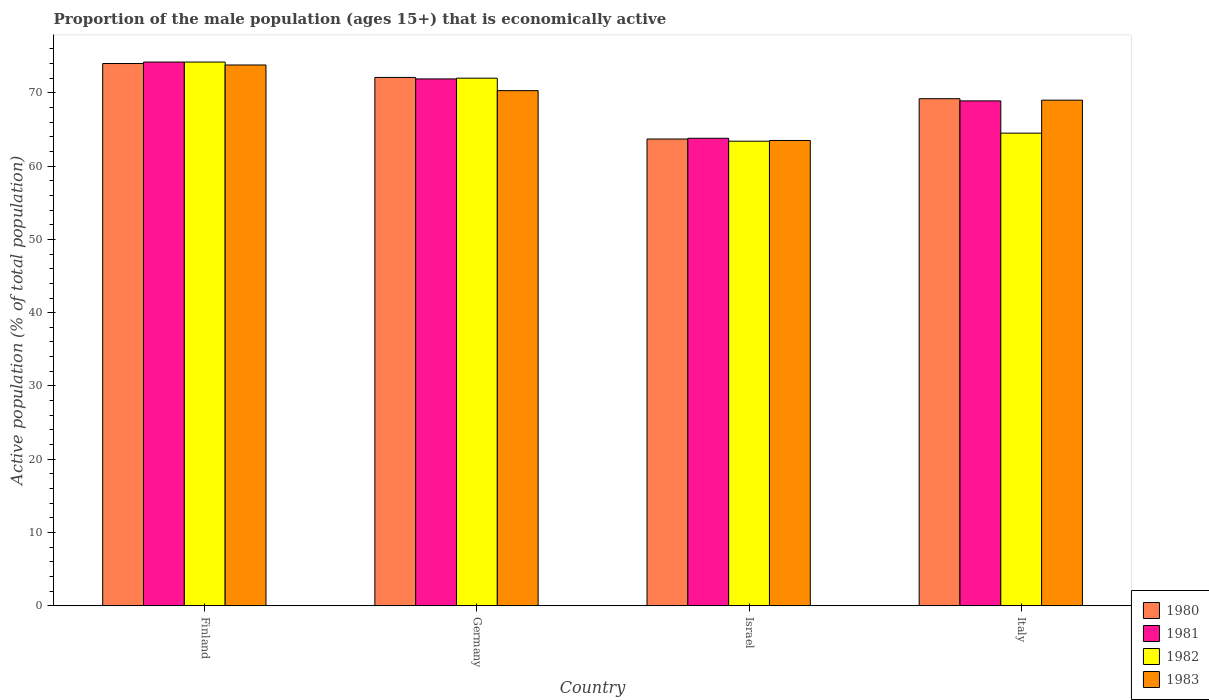Are the number of bars on each tick of the X-axis equal?
Your answer should be compact. Yes. How many bars are there on the 3rd tick from the left?
Keep it short and to the point. 4. What is the proportion of the male population that is economically active in 1982 in Finland?
Ensure brevity in your answer.  74.2. Across all countries, what is the maximum proportion of the male population that is economically active in 1983?
Provide a succinct answer. 73.8. Across all countries, what is the minimum proportion of the male population that is economically active in 1981?
Make the answer very short. 63.8. What is the total proportion of the male population that is economically active in 1981 in the graph?
Provide a short and direct response. 278.8. What is the difference between the proportion of the male population that is economically active in 1980 in Finland and that in Germany?
Your answer should be compact. 1.9. What is the difference between the proportion of the male population that is economically active in 1980 in Finland and the proportion of the male population that is economically active in 1983 in Italy?
Keep it short and to the point. 5. What is the average proportion of the male population that is economically active in 1983 per country?
Offer a terse response. 69.15. What is the difference between the proportion of the male population that is economically active of/in 1981 and proportion of the male population that is economically active of/in 1980 in Germany?
Your answer should be very brief. -0.2. What is the ratio of the proportion of the male population that is economically active in 1983 in Finland to that in Italy?
Your answer should be very brief. 1.07. What is the difference between the highest and the second highest proportion of the male population that is economically active in 1982?
Provide a short and direct response. -2.2. What is the difference between the highest and the lowest proportion of the male population that is economically active in 1982?
Your answer should be very brief. 10.8. Is it the case that in every country, the sum of the proportion of the male population that is economically active in 1981 and proportion of the male population that is economically active in 1982 is greater than the sum of proportion of the male population that is economically active in 1980 and proportion of the male population that is economically active in 1983?
Ensure brevity in your answer.  No. What does the 3rd bar from the left in Israel represents?
Keep it short and to the point. 1982. Is it the case that in every country, the sum of the proportion of the male population that is economically active in 1982 and proportion of the male population that is economically active in 1981 is greater than the proportion of the male population that is economically active in 1980?
Make the answer very short. Yes. How many bars are there?
Provide a short and direct response. 16. Are the values on the major ticks of Y-axis written in scientific E-notation?
Your answer should be compact. No. Does the graph contain any zero values?
Offer a terse response. No. Does the graph contain grids?
Your answer should be very brief. No. How are the legend labels stacked?
Offer a very short reply. Vertical. What is the title of the graph?
Provide a succinct answer. Proportion of the male population (ages 15+) that is economically active. Does "2005" appear as one of the legend labels in the graph?
Keep it short and to the point. No. What is the label or title of the Y-axis?
Keep it short and to the point. Active population (% of total population). What is the Active population (% of total population) of 1980 in Finland?
Provide a short and direct response. 74. What is the Active population (% of total population) of 1981 in Finland?
Ensure brevity in your answer.  74.2. What is the Active population (% of total population) in 1982 in Finland?
Ensure brevity in your answer.  74.2. What is the Active population (% of total population) in 1983 in Finland?
Provide a succinct answer. 73.8. What is the Active population (% of total population) in 1980 in Germany?
Make the answer very short. 72.1. What is the Active population (% of total population) in 1981 in Germany?
Your response must be concise. 71.9. What is the Active population (% of total population) in 1982 in Germany?
Your answer should be very brief. 72. What is the Active population (% of total population) of 1983 in Germany?
Your answer should be very brief. 70.3. What is the Active population (% of total population) in 1980 in Israel?
Provide a short and direct response. 63.7. What is the Active population (% of total population) in 1981 in Israel?
Ensure brevity in your answer.  63.8. What is the Active population (% of total population) of 1982 in Israel?
Provide a short and direct response. 63.4. What is the Active population (% of total population) of 1983 in Israel?
Keep it short and to the point. 63.5. What is the Active population (% of total population) in 1980 in Italy?
Provide a short and direct response. 69.2. What is the Active population (% of total population) of 1981 in Italy?
Offer a very short reply. 68.9. What is the Active population (% of total population) in 1982 in Italy?
Your answer should be very brief. 64.5. What is the Active population (% of total population) in 1983 in Italy?
Make the answer very short. 69. Across all countries, what is the maximum Active population (% of total population) of 1980?
Ensure brevity in your answer.  74. Across all countries, what is the maximum Active population (% of total population) in 1981?
Offer a terse response. 74.2. Across all countries, what is the maximum Active population (% of total population) in 1982?
Keep it short and to the point. 74.2. Across all countries, what is the maximum Active population (% of total population) in 1983?
Provide a succinct answer. 73.8. Across all countries, what is the minimum Active population (% of total population) of 1980?
Provide a short and direct response. 63.7. Across all countries, what is the minimum Active population (% of total population) of 1981?
Your response must be concise. 63.8. Across all countries, what is the minimum Active population (% of total population) of 1982?
Provide a short and direct response. 63.4. Across all countries, what is the minimum Active population (% of total population) in 1983?
Offer a terse response. 63.5. What is the total Active population (% of total population) in 1980 in the graph?
Your answer should be very brief. 279. What is the total Active population (% of total population) of 1981 in the graph?
Provide a succinct answer. 278.8. What is the total Active population (% of total population) in 1982 in the graph?
Ensure brevity in your answer.  274.1. What is the total Active population (% of total population) in 1983 in the graph?
Make the answer very short. 276.6. What is the difference between the Active population (% of total population) in 1981 in Finland and that in Germany?
Your answer should be very brief. 2.3. What is the difference between the Active population (% of total population) of 1982 in Finland and that in Germany?
Make the answer very short. 2.2. What is the difference between the Active population (% of total population) of 1982 in Finland and that in Israel?
Make the answer very short. 10.8. What is the difference between the Active population (% of total population) of 1983 in Finland and that in Israel?
Provide a short and direct response. 10.3. What is the difference between the Active population (% of total population) of 1980 in Finland and that in Italy?
Provide a short and direct response. 4.8. What is the difference between the Active population (% of total population) of 1981 in Finland and that in Italy?
Keep it short and to the point. 5.3. What is the difference between the Active population (% of total population) in 1982 in Finland and that in Italy?
Provide a succinct answer. 9.7. What is the difference between the Active population (% of total population) in 1983 in Germany and that in Italy?
Your answer should be very brief. 1.3. What is the difference between the Active population (% of total population) in 1981 in Israel and that in Italy?
Your response must be concise. -5.1. What is the difference between the Active population (% of total population) in 1983 in Israel and that in Italy?
Offer a terse response. -5.5. What is the difference between the Active population (% of total population) of 1980 in Finland and the Active population (% of total population) of 1983 in Germany?
Offer a very short reply. 3.7. What is the difference between the Active population (% of total population) in 1981 in Finland and the Active population (% of total population) in 1982 in Germany?
Your answer should be very brief. 2.2. What is the difference between the Active population (% of total population) of 1981 in Finland and the Active population (% of total population) of 1983 in Germany?
Offer a terse response. 3.9. What is the difference between the Active population (% of total population) in 1982 in Finland and the Active population (% of total population) in 1983 in Germany?
Provide a succinct answer. 3.9. What is the difference between the Active population (% of total population) in 1980 in Finland and the Active population (% of total population) in 1981 in Israel?
Keep it short and to the point. 10.2. What is the difference between the Active population (% of total population) of 1980 in Finland and the Active population (% of total population) of 1982 in Israel?
Your response must be concise. 10.6. What is the difference between the Active population (% of total population) in 1981 in Finland and the Active population (% of total population) in 1982 in Israel?
Offer a very short reply. 10.8. What is the difference between the Active population (% of total population) in 1981 in Finland and the Active population (% of total population) in 1983 in Israel?
Provide a short and direct response. 10.7. What is the difference between the Active population (% of total population) of 1980 in Finland and the Active population (% of total population) of 1982 in Italy?
Provide a short and direct response. 9.5. What is the difference between the Active population (% of total population) in 1980 in Finland and the Active population (% of total population) in 1983 in Italy?
Give a very brief answer. 5. What is the difference between the Active population (% of total population) of 1981 in Finland and the Active population (% of total population) of 1983 in Italy?
Give a very brief answer. 5.2. What is the difference between the Active population (% of total population) of 1982 in Finland and the Active population (% of total population) of 1983 in Italy?
Offer a terse response. 5.2. What is the difference between the Active population (% of total population) of 1980 in Germany and the Active population (% of total population) of 1981 in Israel?
Offer a very short reply. 8.3. What is the difference between the Active population (% of total population) in 1980 in Germany and the Active population (% of total population) in 1982 in Israel?
Provide a short and direct response. 8.7. What is the difference between the Active population (% of total population) of 1980 in Germany and the Active population (% of total population) of 1983 in Israel?
Your answer should be very brief. 8.6. What is the difference between the Active population (% of total population) of 1982 in Germany and the Active population (% of total population) of 1983 in Israel?
Your answer should be compact. 8.5. What is the difference between the Active population (% of total population) of 1980 in Germany and the Active population (% of total population) of 1981 in Italy?
Give a very brief answer. 3.2. What is the difference between the Active population (% of total population) of 1980 in Germany and the Active population (% of total population) of 1982 in Italy?
Offer a very short reply. 7.6. What is the difference between the Active population (% of total population) in 1980 in Germany and the Active population (% of total population) in 1983 in Italy?
Provide a succinct answer. 3.1. What is the difference between the Active population (% of total population) of 1980 in Israel and the Active population (% of total population) of 1981 in Italy?
Offer a terse response. -5.2. What is the difference between the Active population (% of total population) in 1980 in Israel and the Active population (% of total population) in 1982 in Italy?
Give a very brief answer. -0.8. What is the difference between the Active population (% of total population) of 1980 in Israel and the Active population (% of total population) of 1983 in Italy?
Give a very brief answer. -5.3. What is the difference between the Active population (% of total population) of 1981 in Israel and the Active population (% of total population) of 1982 in Italy?
Your answer should be compact. -0.7. What is the difference between the Active population (% of total population) of 1982 in Israel and the Active population (% of total population) of 1983 in Italy?
Your response must be concise. -5.6. What is the average Active population (% of total population) in 1980 per country?
Keep it short and to the point. 69.75. What is the average Active population (% of total population) in 1981 per country?
Offer a very short reply. 69.7. What is the average Active population (% of total population) of 1982 per country?
Give a very brief answer. 68.53. What is the average Active population (% of total population) in 1983 per country?
Make the answer very short. 69.15. What is the difference between the Active population (% of total population) in 1980 and Active population (% of total population) in 1981 in Finland?
Ensure brevity in your answer.  -0.2. What is the difference between the Active population (% of total population) of 1980 and Active population (% of total population) of 1982 in Finland?
Your response must be concise. -0.2. What is the difference between the Active population (% of total population) in 1980 and Active population (% of total population) in 1983 in Finland?
Make the answer very short. 0.2. What is the difference between the Active population (% of total population) in 1980 and Active population (% of total population) in 1981 in Germany?
Give a very brief answer. 0.2. What is the difference between the Active population (% of total population) in 1980 and Active population (% of total population) in 1983 in Germany?
Provide a short and direct response. 1.8. What is the difference between the Active population (% of total population) in 1980 and Active population (% of total population) in 1981 in Israel?
Make the answer very short. -0.1. What is the difference between the Active population (% of total population) in 1980 and Active population (% of total population) in 1982 in Italy?
Make the answer very short. 4.7. What is the ratio of the Active population (% of total population) of 1980 in Finland to that in Germany?
Provide a succinct answer. 1.03. What is the ratio of the Active population (% of total population) in 1981 in Finland to that in Germany?
Give a very brief answer. 1.03. What is the ratio of the Active population (% of total population) in 1982 in Finland to that in Germany?
Provide a short and direct response. 1.03. What is the ratio of the Active population (% of total population) of 1983 in Finland to that in Germany?
Your answer should be compact. 1.05. What is the ratio of the Active population (% of total population) of 1980 in Finland to that in Israel?
Make the answer very short. 1.16. What is the ratio of the Active population (% of total population) of 1981 in Finland to that in Israel?
Ensure brevity in your answer.  1.16. What is the ratio of the Active population (% of total population) in 1982 in Finland to that in Israel?
Provide a short and direct response. 1.17. What is the ratio of the Active population (% of total population) of 1983 in Finland to that in Israel?
Keep it short and to the point. 1.16. What is the ratio of the Active population (% of total population) of 1980 in Finland to that in Italy?
Your answer should be very brief. 1.07. What is the ratio of the Active population (% of total population) in 1982 in Finland to that in Italy?
Keep it short and to the point. 1.15. What is the ratio of the Active population (% of total population) in 1983 in Finland to that in Italy?
Offer a terse response. 1.07. What is the ratio of the Active population (% of total population) of 1980 in Germany to that in Israel?
Your answer should be compact. 1.13. What is the ratio of the Active population (% of total population) in 1981 in Germany to that in Israel?
Your answer should be compact. 1.13. What is the ratio of the Active population (% of total population) in 1982 in Germany to that in Israel?
Your answer should be very brief. 1.14. What is the ratio of the Active population (% of total population) in 1983 in Germany to that in Israel?
Your response must be concise. 1.11. What is the ratio of the Active population (% of total population) of 1980 in Germany to that in Italy?
Your answer should be very brief. 1.04. What is the ratio of the Active population (% of total population) in 1981 in Germany to that in Italy?
Keep it short and to the point. 1.04. What is the ratio of the Active population (% of total population) in 1982 in Germany to that in Italy?
Your answer should be very brief. 1.12. What is the ratio of the Active population (% of total population) of 1983 in Germany to that in Italy?
Provide a short and direct response. 1.02. What is the ratio of the Active population (% of total population) of 1980 in Israel to that in Italy?
Ensure brevity in your answer.  0.92. What is the ratio of the Active population (% of total population) in 1981 in Israel to that in Italy?
Your answer should be compact. 0.93. What is the ratio of the Active population (% of total population) of 1982 in Israel to that in Italy?
Offer a very short reply. 0.98. What is the ratio of the Active population (% of total population) in 1983 in Israel to that in Italy?
Your answer should be compact. 0.92. What is the difference between the highest and the second highest Active population (% of total population) in 1980?
Give a very brief answer. 1.9. What is the difference between the highest and the second highest Active population (% of total population) of 1982?
Give a very brief answer. 2.2. What is the difference between the highest and the lowest Active population (% of total population) of 1981?
Make the answer very short. 10.4. 